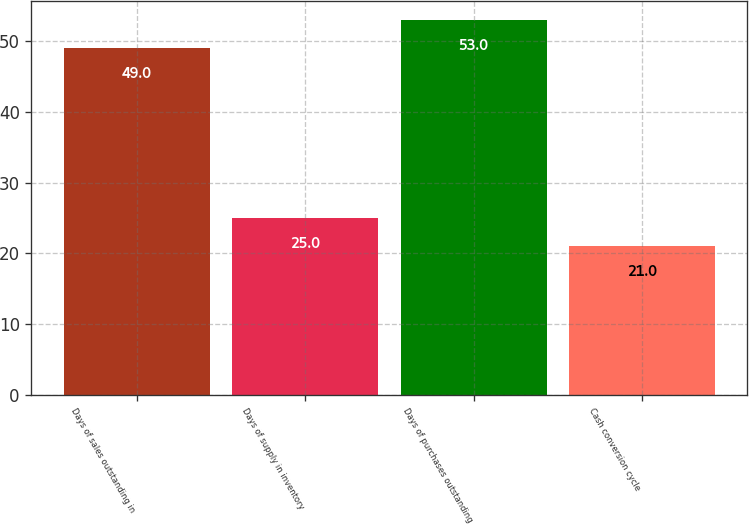Convert chart to OTSL. <chart><loc_0><loc_0><loc_500><loc_500><bar_chart><fcel>Days of sales outstanding in<fcel>Days of supply in inventory<fcel>Days of purchases outstanding<fcel>Cash conversion cycle<nl><fcel>49<fcel>25<fcel>53<fcel>21<nl></chart> 